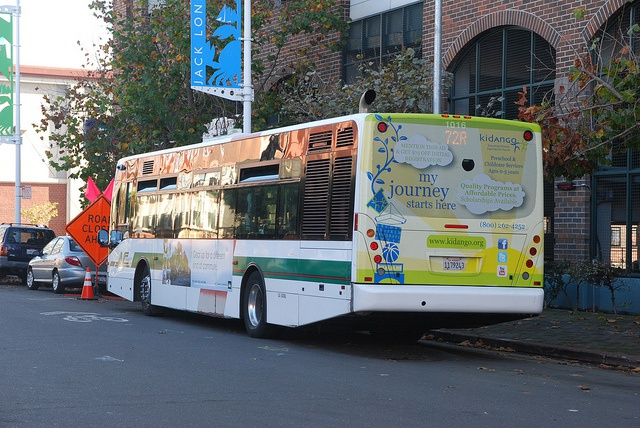Describe the objects in this image and their specific colors. I can see bus in white, darkgray, black, and olive tones, car in white, black, gray, lightgray, and darkgray tones, and car in white, black, navy, darkblue, and gray tones in this image. 